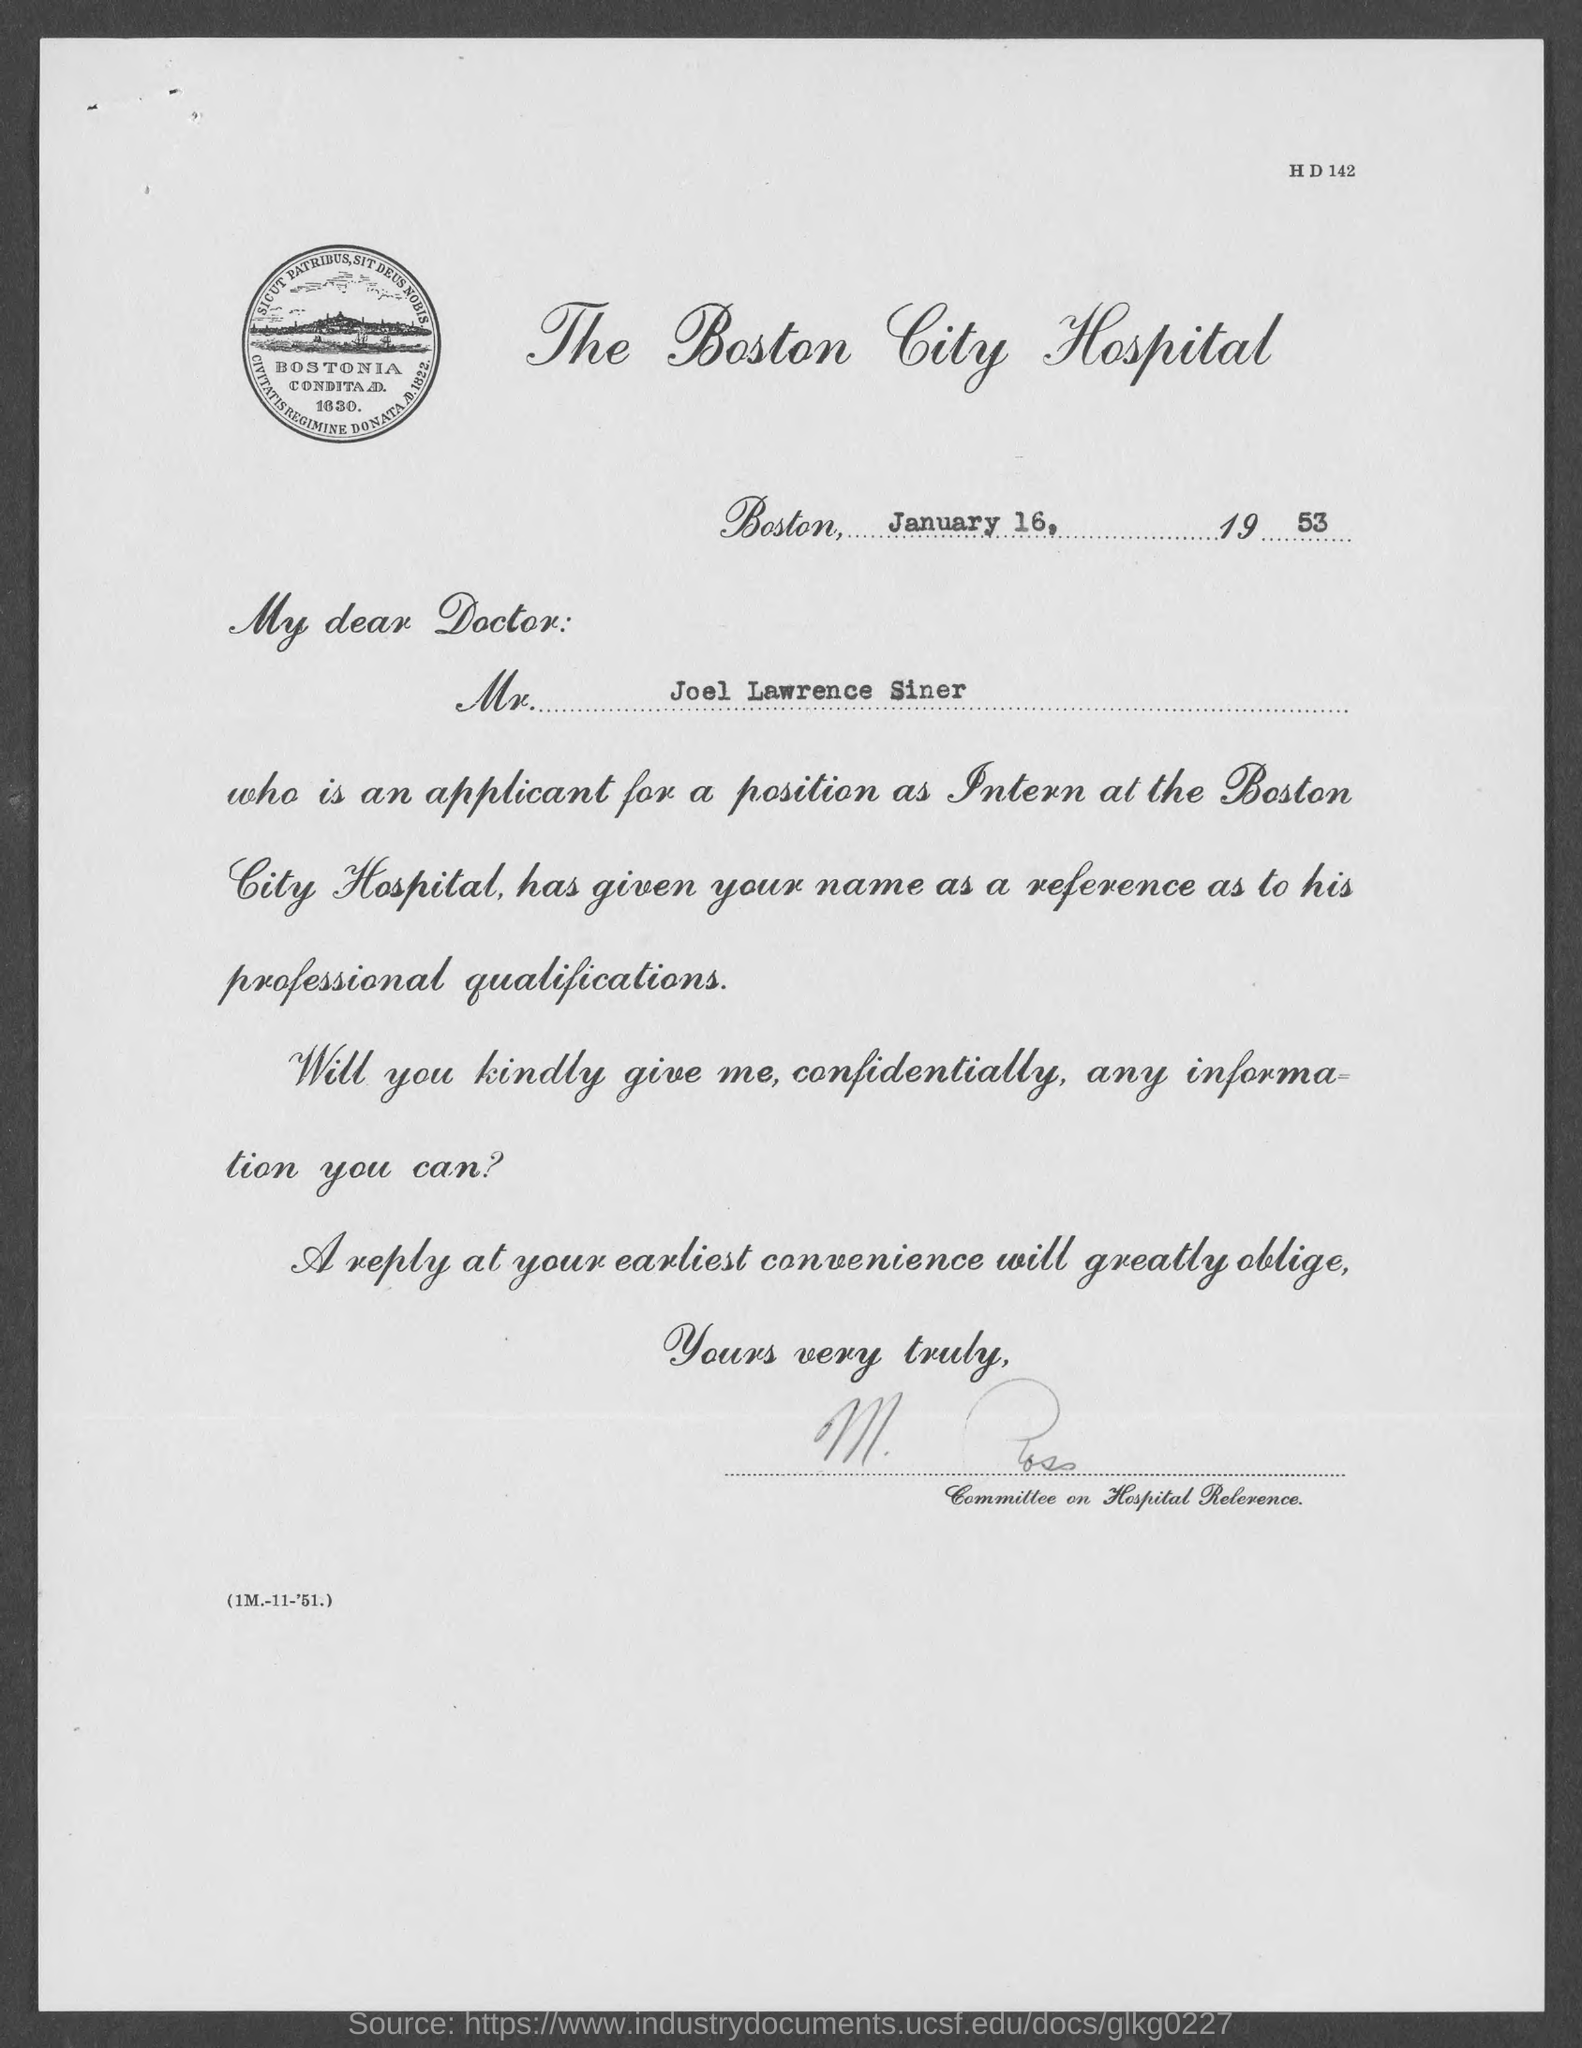What is the position that applicant applied for?
Keep it short and to the point. INTERN. What is the name of the applicant?
Your answer should be compact. JOEL LAWRENCE SINER. From which place the letter is written from?
Your response must be concise. BOSTON. On which date the letter is dated on?
Your answer should be compact. January 16, 1953. 